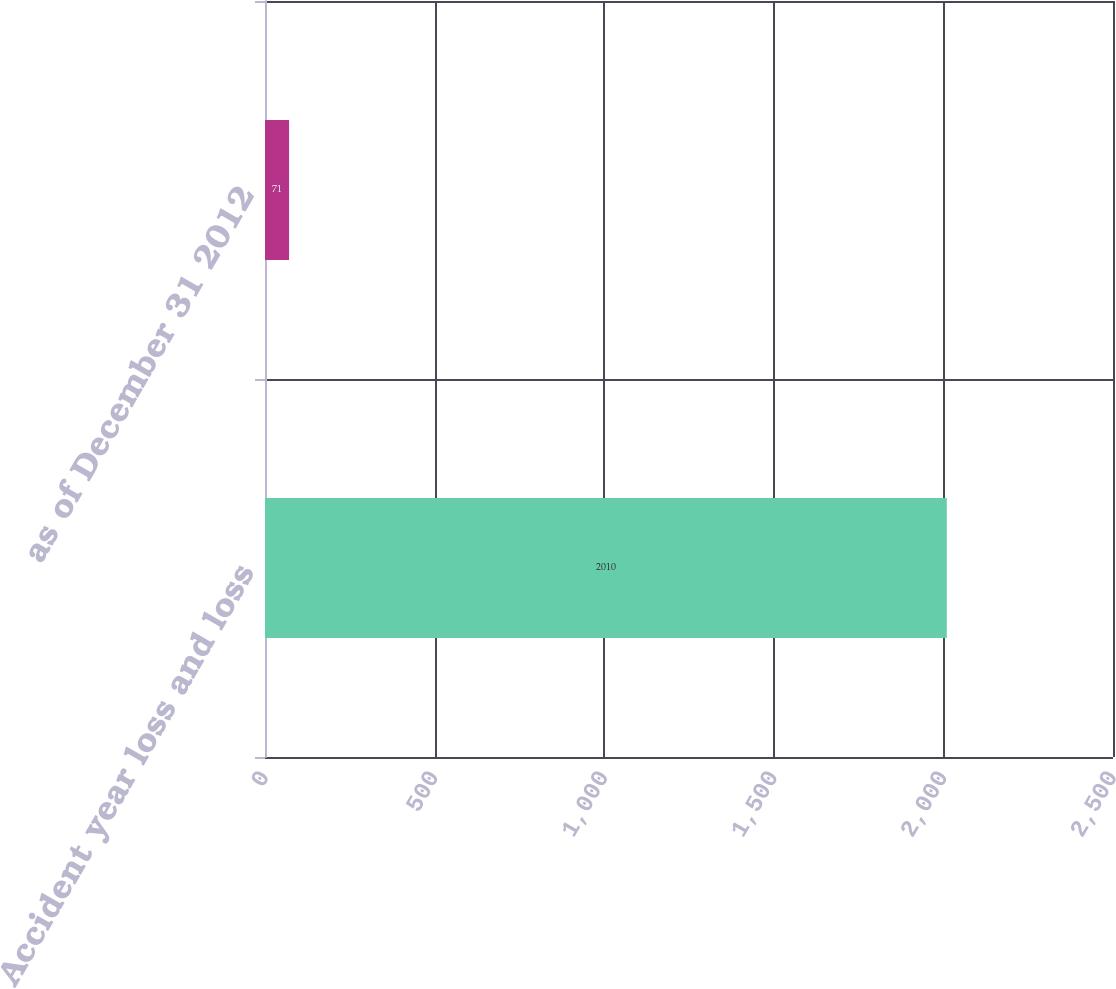Convert chart to OTSL. <chart><loc_0><loc_0><loc_500><loc_500><bar_chart><fcel>Accident year loss and loss<fcel>as of December 31 2012<nl><fcel>2010<fcel>71<nl></chart> 